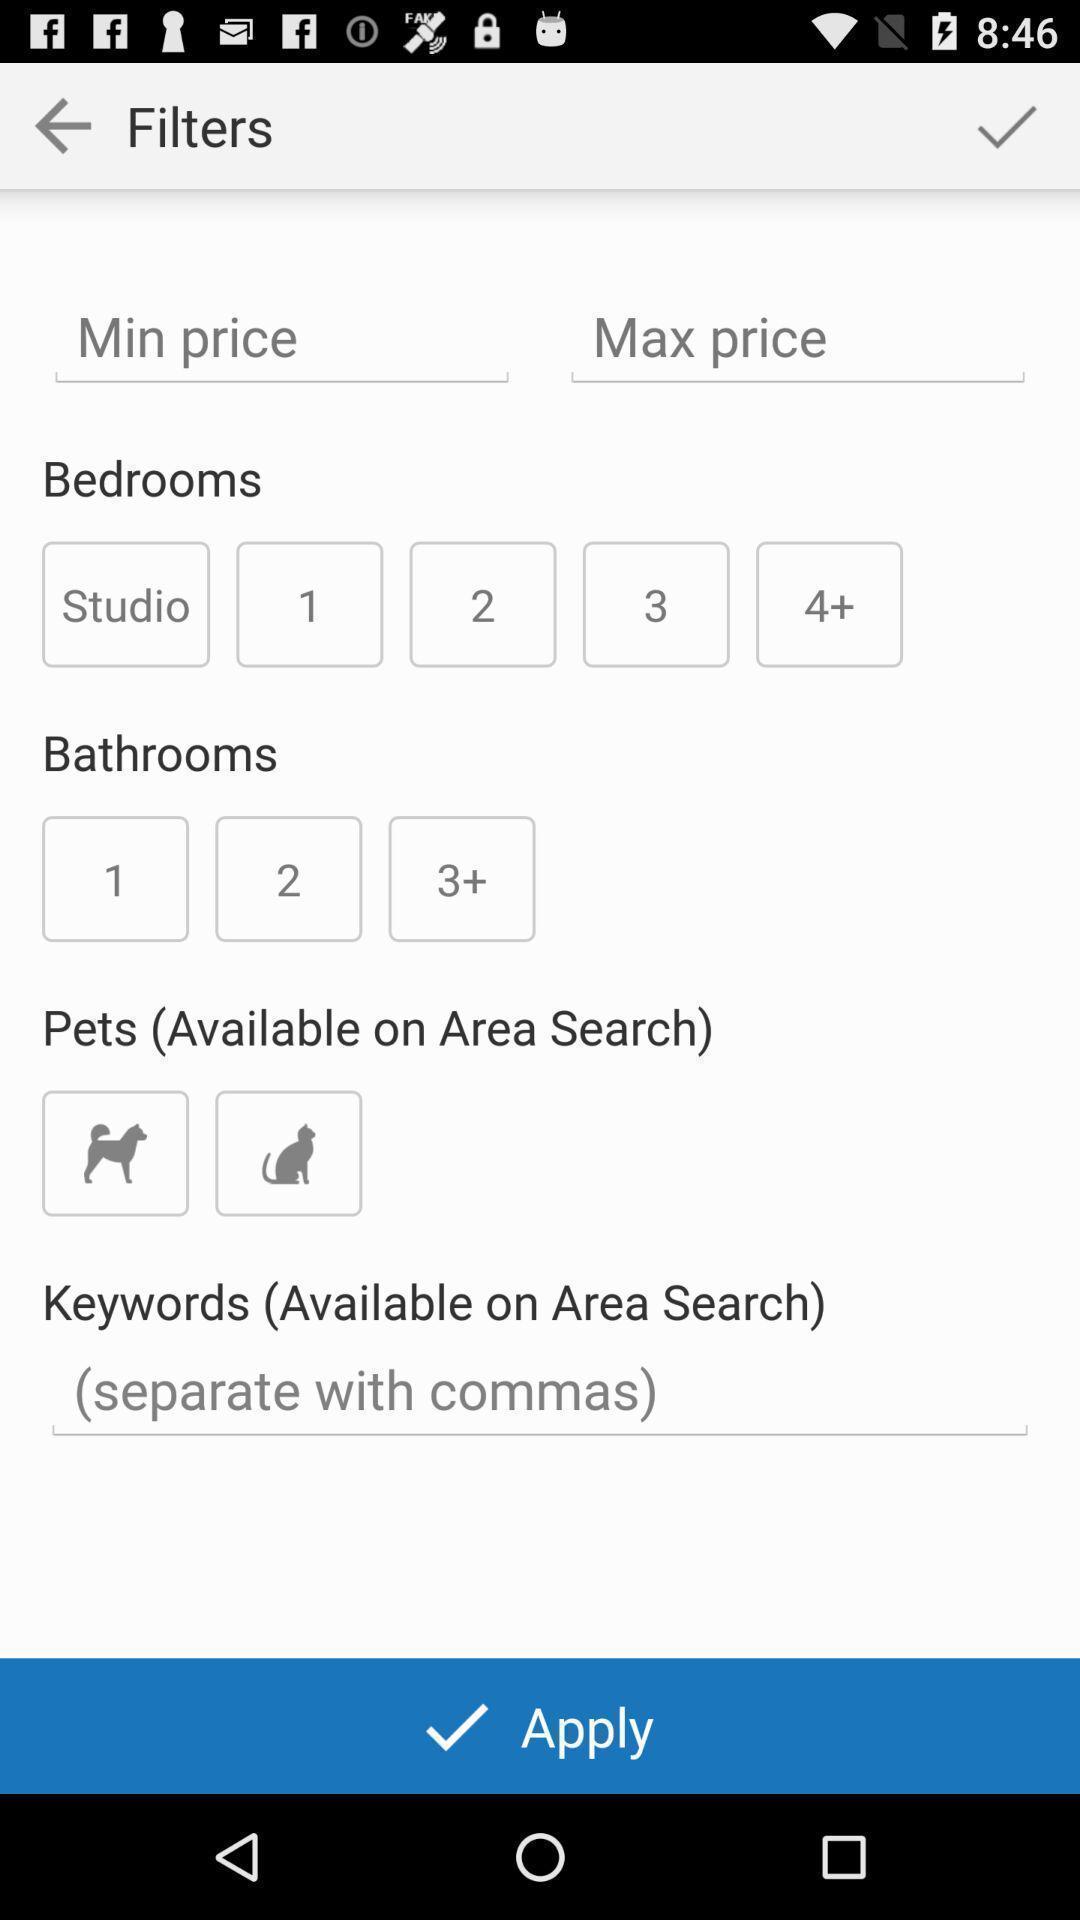What is the overall content of this screenshot? Page displaying various filters. 